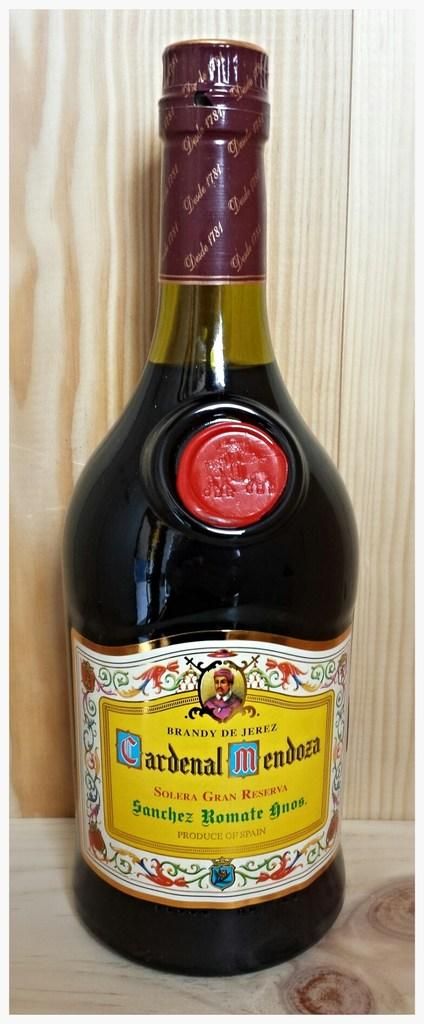<image>
Offer a succinct explanation of the picture presented. A bottle of Cardenal Mendoza has a colorful label on it. 